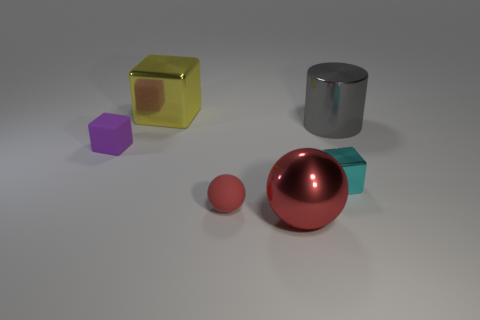There is a rubber object that is in front of the purple matte cube; does it have the same size as the shiny thing that is in front of the tiny cyan block?
Your response must be concise. No. How many metallic spheres have the same color as the matte sphere?
Your answer should be very brief. 1. There is a yellow metal cube; is it the same size as the metal cube that is in front of the gray cylinder?
Provide a succinct answer. No. There is a metal block right of the shiny thing that is to the left of the rubber object to the right of the yellow metallic cube; what size is it?
Provide a succinct answer. Small. There is a red rubber sphere; what number of tiny rubber cubes are on the left side of it?
Provide a short and direct response. 1. The large object in front of the tiny block to the right of the red shiny thing is made of what material?
Offer a terse response. Metal. Do the metallic ball and the gray object have the same size?
Your answer should be very brief. Yes. How many objects are things that are to the right of the large red metal ball or metallic cubes behind the purple block?
Offer a terse response. 3. Is the number of tiny cubes to the right of the red matte thing greater than the number of large green rubber balls?
Make the answer very short. Yes. How many other things are the same shape as the yellow metallic thing?
Keep it short and to the point. 2. 